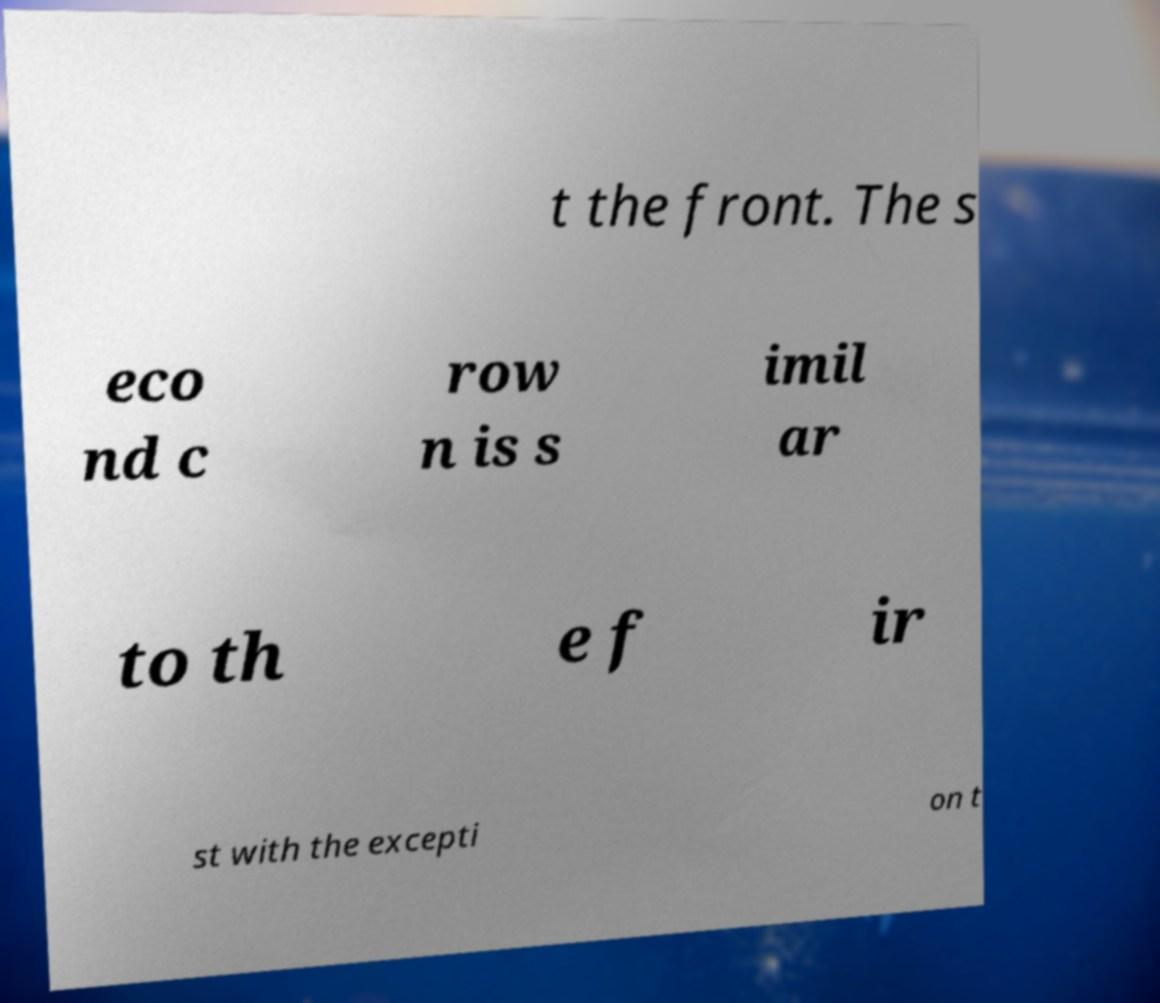Could you assist in decoding the text presented in this image and type it out clearly? t the front. The s eco nd c row n is s imil ar to th e f ir st with the excepti on t 